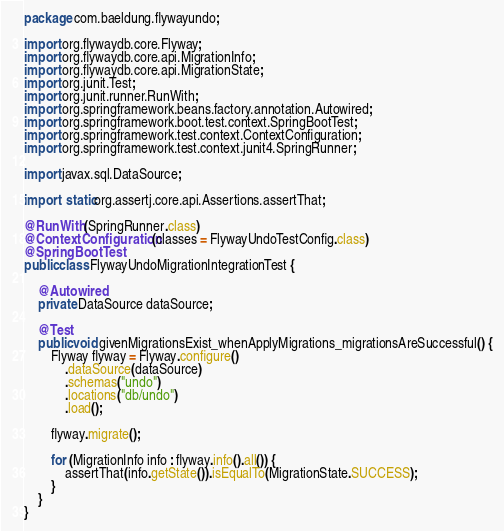Convert code to text. <code><loc_0><loc_0><loc_500><loc_500><_Java_>package com.baeldung.flywayundo;

import org.flywaydb.core.Flyway;
import org.flywaydb.core.api.MigrationInfo;
import org.flywaydb.core.api.MigrationState;
import org.junit.Test;
import org.junit.runner.RunWith;
import org.springframework.beans.factory.annotation.Autowired;
import org.springframework.boot.test.context.SpringBootTest;
import org.springframework.test.context.ContextConfiguration;
import org.springframework.test.context.junit4.SpringRunner;

import javax.sql.DataSource;

import static org.assertj.core.api.Assertions.assertThat;

@RunWith(SpringRunner.class)
@ContextConfiguration(classes = FlywayUndoTestConfig.class)
@SpringBootTest
public class FlywayUndoMigrationIntegrationTest {

    @Autowired
    private DataSource dataSource;

    @Test
    public void givenMigrationsExist_whenApplyMigrations_migrationsAreSuccessful() {
        Flyway flyway = Flyway.configure()
            .dataSource(dataSource)
            .schemas("undo")
            .locations("db/undo")
            .load();

        flyway.migrate();

        for (MigrationInfo info : flyway.info().all()) {
            assertThat(info.getState()).isEqualTo(MigrationState.SUCCESS);
        }
    }
}
</code> 